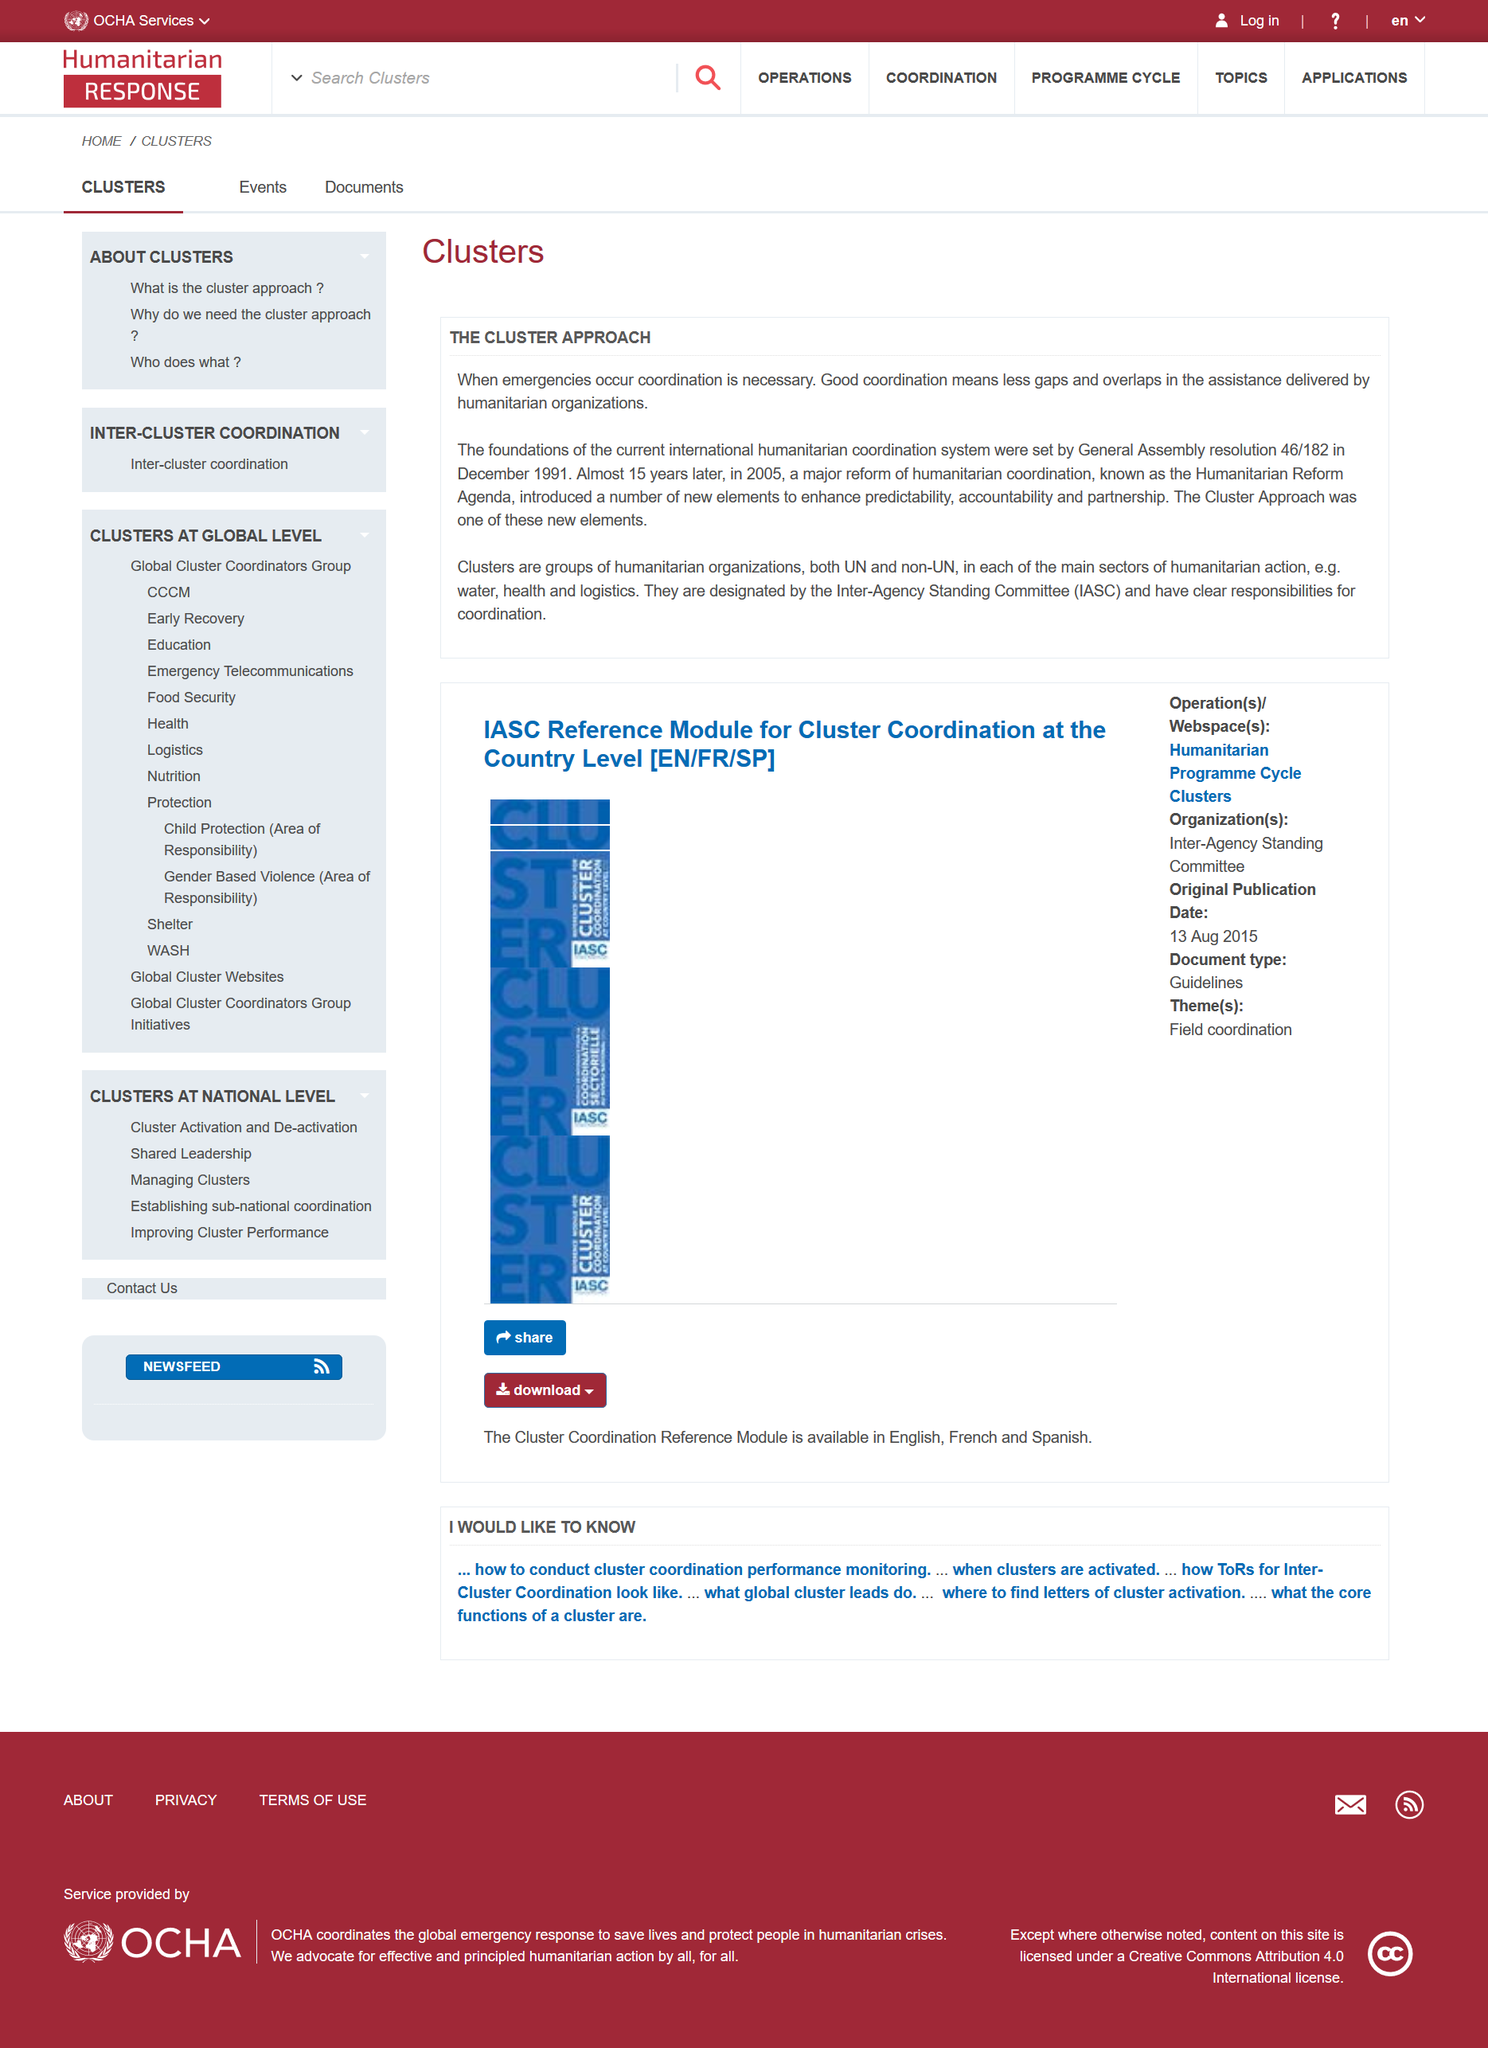Identify some key points in this picture. The cluster approach can lead to fewer gaps and overlaps in the assistance delivered, as good coordination ensures that the support provided is comprehensive and efficient. The cluster approach involves a diverse group of humanitarian organizations, both United Nations and non-United Nations, working together to provide assistance in a given crisis. The Cluster Approach was introduced in 2005. 